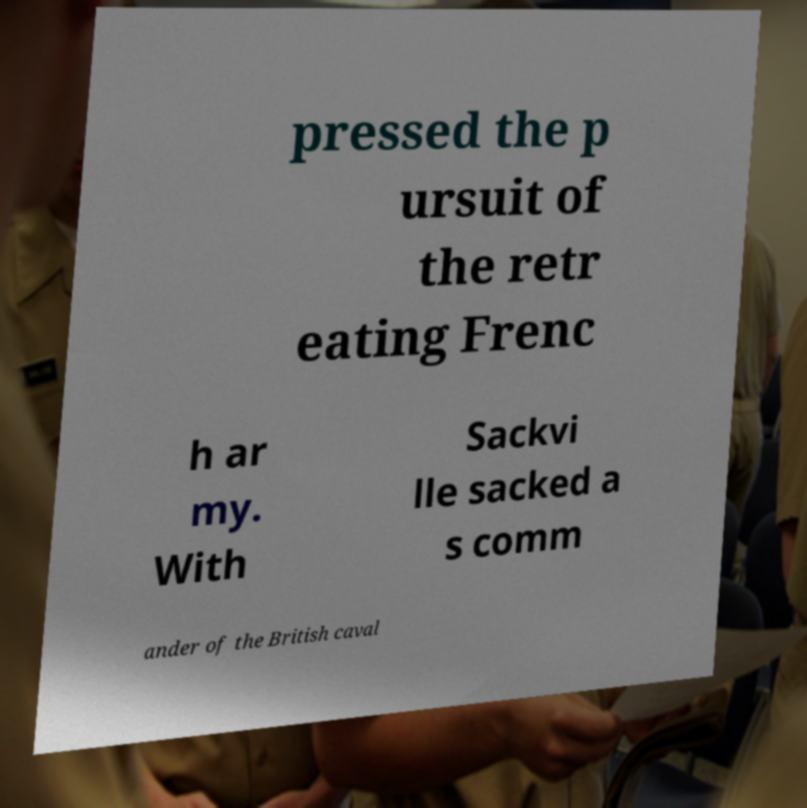Can you accurately transcribe the text from the provided image for me? pressed the p ursuit of the retr eating Frenc h ar my. With Sackvi lle sacked a s comm ander of the British caval 